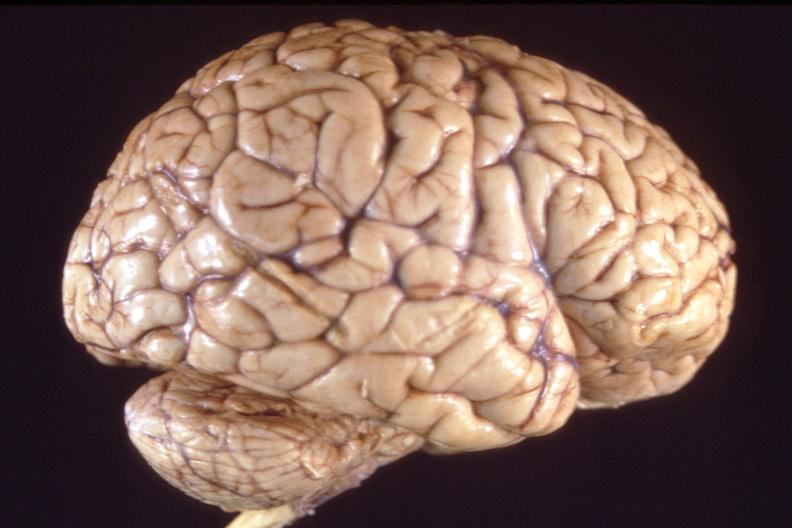does this image show brain, breast cancer metastasis to meninges?
Answer the question using a single word or phrase. Yes 